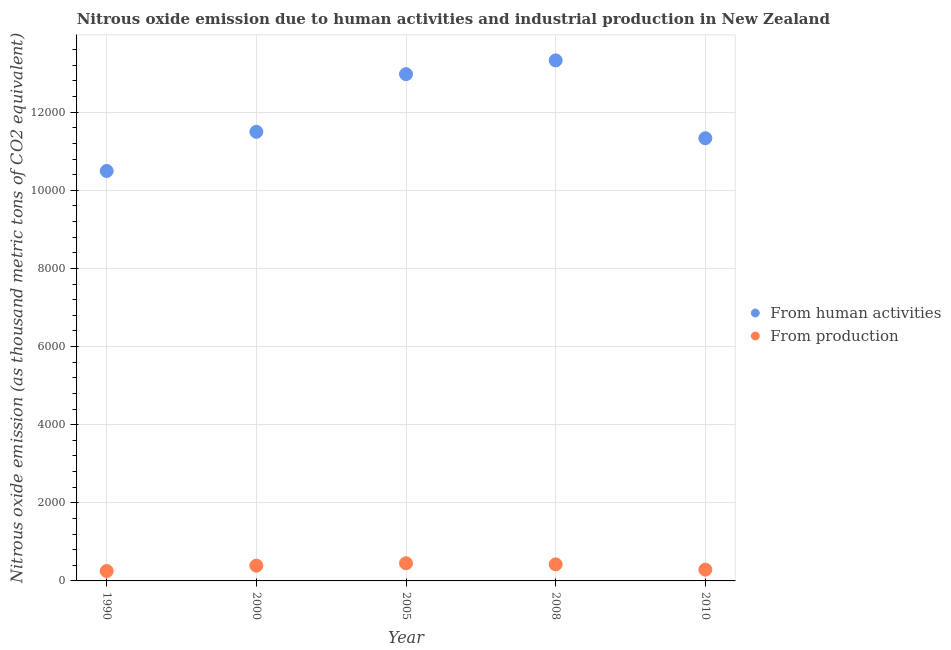What is the amount of emissions from human activities in 2005?
Make the answer very short. 1.30e+04. Across all years, what is the maximum amount of emissions generated from industries?
Your response must be concise. 452.7. Across all years, what is the minimum amount of emissions generated from industries?
Your answer should be compact. 253.4. In which year was the amount of emissions generated from industries minimum?
Offer a very short reply. 1990. What is the total amount of emissions from human activities in the graph?
Give a very brief answer. 5.96e+04. What is the difference between the amount of emissions generated from industries in 1990 and that in 2000?
Your answer should be very brief. -137.1. What is the difference between the amount of emissions from human activities in 1990 and the amount of emissions generated from industries in 2000?
Give a very brief answer. 1.01e+04. What is the average amount of emissions from human activities per year?
Provide a succinct answer. 1.19e+04. In the year 2005, what is the difference between the amount of emissions from human activities and amount of emissions generated from industries?
Provide a succinct answer. 1.25e+04. What is the ratio of the amount of emissions from human activities in 2000 to that in 2005?
Your answer should be compact. 0.89. What is the difference between the highest and the second highest amount of emissions generated from industries?
Your answer should be very brief. 28.7. What is the difference between the highest and the lowest amount of emissions generated from industries?
Offer a very short reply. 199.3. In how many years, is the amount of emissions generated from industries greater than the average amount of emissions generated from industries taken over all years?
Provide a short and direct response. 3. Is the sum of the amount of emissions generated from industries in 2008 and 2010 greater than the maximum amount of emissions from human activities across all years?
Offer a terse response. No. Does the amount of emissions generated from industries monotonically increase over the years?
Your answer should be very brief. No. How many dotlines are there?
Provide a succinct answer. 2. How many years are there in the graph?
Your response must be concise. 5. What is the difference between two consecutive major ticks on the Y-axis?
Keep it short and to the point. 2000. Where does the legend appear in the graph?
Your answer should be compact. Center right. How many legend labels are there?
Keep it short and to the point. 2. What is the title of the graph?
Ensure brevity in your answer.  Nitrous oxide emission due to human activities and industrial production in New Zealand. What is the label or title of the Y-axis?
Provide a succinct answer. Nitrous oxide emission (as thousand metric tons of CO2 equivalent). What is the Nitrous oxide emission (as thousand metric tons of CO2 equivalent) in From human activities in 1990?
Keep it short and to the point. 1.05e+04. What is the Nitrous oxide emission (as thousand metric tons of CO2 equivalent) of From production in 1990?
Your response must be concise. 253.4. What is the Nitrous oxide emission (as thousand metric tons of CO2 equivalent) of From human activities in 2000?
Offer a terse response. 1.15e+04. What is the Nitrous oxide emission (as thousand metric tons of CO2 equivalent) in From production in 2000?
Offer a very short reply. 390.5. What is the Nitrous oxide emission (as thousand metric tons of CO2 equivalent) in From human activities in 2005?
Give a very brief answer. 1.30e+04. What is the Nitrous oxide emission (as thousand metric tons of CO2 equivalent) in From production in 2005?
Make the answer very short. 452.7. What is the Nitrous oxide emission (as thousand metric tons of CO2 equivalent) in From human activities in 2008?
Offer a terse response. 1.33e+04. What is the Nitrous oxide emission (as thousand metric tons of CO2 equivalent) in From production in 2008?
Keep it short and to the point. 424. What is the Nitrous oxide emission (as thousand metric tons of CO2 equivalent) of From human activities in 2010?
Give a very brief answer. 1.13e+04. What is the Nitrous oxide emission (as thousand metric tons of CO2 equivalent) of From production in 2010?
Give a very brief answer. 288.3. Across all years, what is the maximum Nitrous oxide emission (as thousand metric tons of CO2 equivalent) in From human activities?
Your response must be concise. 1.33e+04. Across all years, what is the maximum Nitrous oxide emission (as thousand metric tons of CO2 equivalent) of From production?
Provide a succinct answer. 452.7. Across all years, what is the minimum Nitrous oxide emission (as thousand metric tons of CO2 equivalent) in From human activities?
Ensure brevity in your answer.  1.05e+04. Across all years, what is the minimum Nitrous oxide emission (as thousand metric tons of CO2 equivalent) of From production?
Ensure brevity in your answer.  253.4. What is the total Nitrous oxide emission (as thousand metric tons of CO2 equivalent) in From human activities in the graph?
Ensure brevity in your answer.  5.96e+04. What is the total Nitrous oxide emission (as thousand metric tons of CO2 equivalent) of From production in the graph?
Provide a succinct answer. 1808.9. What is the difference between the Nitrous oxide emission (as thousand metric tons of CO2 equivalent) in From human activities in 1990 and that in 2000?
Provide a short and direct response. -1002.9. What is the difference between the Nitrous oxide emission (as thousand metric tons of CO2 equivalent) in From production in 1990 and that in 2000?
Your response must be concise. -137.1. What is the difference between the Nitrous oxide emission (as thousand metric tons of CO2 equivalent) of From human activities in 1990 and that in 2005?
Make the answer very short. -2478.7. What is the difference between the Nitrous oxide emission (as thousand metric tons of CO2 equivalent) of From production in 1990 and that in 2005?
Your response must be concise. -199.3. What is the difference between the Nitrous oxide emission (as thousand metric tons of CO2 equivalent) in From human activities in 1990 and that in 2008?
Your response must be concise. -2830.6. What is the difference between the Nitrous oxide emission (as thousand metric tons of CO2 equivalent) in From production in 1990 and that in 2008?
Keep it short and to the point. -170.6. What is the difference between the Nitrous oxide emission (as thousand metric tons of CO2 equivalent) in From human activities in 1990 and that in 2010?
Provide a short and direct response. -838.1. What is the difference between the Nitrous oxide emission (as thousand metric tons of CO2 equivalent) of From production in 1990 and that in 2010?
Offer a terse response. -34.9. What is the difference between the Nitrous oxide emission (as thousand metric tons of CO2 equivalent) in From human activities in 2000 and that in 2005?
Give a very brief answer. -1475.8. What is the difference between the Nitrous oxide emission (as thousand metric tons of CO2 equivalent) of From production in 2000 and that in 2005?
Your response must be concise. -62.2. What is the difference between the Nitrous oxide emission (as thousand metric tons of CO2 equivalent) of From human activities in 2000 and that in 2008?
Your response must be concise. -1827.7. What is the difference between the Nitrous oxide emission (as thousand metric tons of CO2 equivalent) in From production in 2000 and that in 2008?
Ensure brevity in your answer.  -33.5. What is the difference between the Nitrous oxide emission (as thousand metric tons of CO2 equivalent) in From human activities in 2000 and that in 2010?
Provide a short and direct response. 164.8. What is the difference between the Nitrous oxide emission (as thousand metric tons of CO2 equivalent) of From production in 2000 and that in 2010?
Make the answer very short. 102.2. What is the difference between the Nitrous oxide emission (as thousand metric tons of CO2 equivalent) of From human activities in 2005 and that in 2008?
Offer a very short reply. -351.9. What is the difference between the Nitrous oxide emission (as thousand metric tons of CO2 equivalent) of From production in 2005 and that in 2008?
Ensure brevity in your answer.  28.7. What is the difference between the Nitrous oxide emission (as thousand metric tons of CO2 equivalent) of From human activities in 2005 and that in 2010?
Ensure brevity in your answer.  1640.6. What is the difference between the Nitrous oxide emission (as thousand metric tons of CO2 equivalent) in From production in 2005 and that in 2010?
Offer a terse response. 164.4. What is the difference between the Nitrous oxide emission (as thousand metric tons of CO2 equivalent) in From human activities in 2008 and that in 2010?
Provide a succinct answer. 1992.5. What is the difference between the Nitrous oxide emission (as thousand metric tons of CO2 equivalent) of From production in 2008 and that in 2010?
Offer a very short reply. 135.7. What is the difference between the Nitrous oxide emission (as thousand metric tons of CO2 equivalent) in From human activities in 1990 and the Nitrous oxide emission (as thousand metric tons of CO2 equivalent) in From production in 2000?
Give a very brief answer. 1.01e+04. What is the difference between the Nitrous oxide emission (as thousand metric tons of CO2 equivalent) in From human activities in 1990 and the Nitrous oxide emission (as thousand metric tons of CO2 equivalent) in From production in 2005?
Keep it short and to the point. 1.00e+04. What is the difference between the Nitrous oxide emission (as thousand metric tons of CO2 equivalent) in From human activities in 1990 and the Nitrous oxide emission (as thousand metric tons of CO2 equivalent) in From production in 2008?
Provide a succinct answer. 1.01e+04. What is the difference between the Nitrous oxide emission (as thousand metric tons of CO2 equivalent) of From human activities in 1990 and the Nitrous oxide emission (as thousand metric tons of CO2 equivalent) of From production in 2010?
Your answer should be compact. 1.02e+04. What is the difference between the Nitrous oxide emission (as thousand metric tons of CO2 equivalent) in From human activities in 2000 and the Nitrous oxide emission (as thousand metric tons of CO2 equivalent) in From production in 2005?
Offer a terse response. 1.10e+04. What is the difference between the Nitrous oxide emission (as thousand metric tons of CO2 equivalent) in From human activities in 2000 and the Nitrous oxide emission (as thousand metric tons of CO2 equivalent) in From production in 2008?
Keep it short and to the point. 1.11e+04. What is the difference between the Nitrous oxide emission (as thousand metric tons of CO2 equivalent) of From human activities in 2000 and the Nitrous oxide emission (as thousand metric tons of CO2 equivalent) of From production in 2010?
Make the answer very short. 1.12e+04. What is the difference between the Nitrous oxide emission (as thousand metric tons of CO2 equivalent) in From human activities in 2005 and the Nitrous oxide emission (as thousand metric tons of CO2 equivalent) in From production in 2008?
Offer a very short reply. 1.26e+04. What is the difference between the Nitrous oxide emission (as thousand metric tons of CO2 equivalent) of From human activities in 2005 and the Nitrous oxide emission (as thousand metric tons of CO2 equivalent) of From production in 2010?
Provide a succinct answer. 1.27e+04. What is the difference between the Nitrous oxide emission (as thousand metric tons of CO2 equivalent) of From human activities in 2008 and the Nitrous oxide emission (as thousand metric tons of CO2 equivalent) of From production in 2010?
Provide a short and direct response. 1.30e+04. What is the average Nitrous oxide emission (as thousand metric tons of CO2 equivalent) in From human activities per year?
Give a very brief answer. 1.19e+04. What is the average Nitrous oxide emission (as thousand metric tons of CO2 equivalent) of From production per year?
Offer a terse response. 361.78. In the year 1990, what is the difference between the Nitrous oxide emission (as thousand metric tons of CO2 equivalent) in From human activities and Nitrous oxide emission (as thousand metric tons of CO2 equivalent) in From production?
Offer a terse response. 1.02e+04. In the year 2000, what is the difference between the Nitrous oxide emission (as thousand metric tons of CO2 equivalent) in From human activities and Nitrous oxide emission (as thousand metric tons of CO2 equivalent) in From production?
Ensure brevity in your answer.  1.11e+04. In the year 2005, what is the difference between the Nitrous oxide emission (as thousand metric tons of CO2 equivalent) in From human activities and Nitrous oxide emission (as thousand metric tons of CO2 equivalent) in From production?
Your response must be concise. 1.25e+04. In the year 2008, what is the difference between the Nitrous oxide emission (as thousand metric tons of CO2 equivalent) of From human activities and Nitrous oxide emission (as thousand metric tons of CO2 equivalent) of From production?
Provide a short and direct response. 1.29e+04. In the year 2010, what is the difference between the Nitrous oxide emission (as thousand metric tons of CO2 equivalent) of From human activities and Nitrous oxide emission (as thousand metric tons of CO2 equivalent) of From production?
Offer a very short reply. 1.10e+04. What is the ratio of the Nitrous oxide emission (as thousand metric tons of CO2 equivalent) of From human activities in 1990 to that in 2000?
Your answer should be very brief. 0.91. What is the ratio of the Nitrous oxide emission (as thousand metric tons of CO2 equivalent) in From production in 1990 to that in 2000?
Your answer should be compact. 0.65. What is the ratio of the Nitrous oxide emission (as thousand metric tons of CO2 equivalent) of From human activities in 1990 to that in 2005?
Your response must be concise. 0.81. What is the ratio of the Nitrous oxide emission (as thousand metric tons of CO2 equivalent) in From production in 1990 to that in 2005?
Provide a short and direct response. 0.56. What is the ratio of the Nitrous oxide emission (as thousand metric tons of CO2 equivalent) in From human activities in 1990 to that in 2008?
Provide a succinct answer. 0.79. What is the ratio of the Nitrous oxide emission (as thousand metric tons of CO2 equivalent) in From production in 1990 to that in 2008?
Your response must be concise. 0.6. What is the ratio of the Nitrous oxide emission (as thousand metric tons of CO2 equivalent) in From human activities in 1990 to that in 2010?
Give a very brief answer. 0.93. What is the ratio of the Nitrous oxide emission (as thousand metric tons of CO2 equivalent) in From production in 1990 to that in 2010?
Offer a very short reply. 0.88. What is the ratio of the Nitrous oxide emission (as thousand metric tons of CO2 equivalent) of From human activities in 2000 to that in 2005?
Ensure brevity in your answer.  0.89. What is the ratio of the Nitrous oxide emission (as thousand metric tons of CO2 equivalent) of From production in 2000 to that in 2005?
Provide a succinct answer. 0.86. What is the ratio of the Nitrous oxide emission (as thousand metric tons of CO2 equivalent) in From human activities in 2000 to that in 2008?
Ensure brevity in your answer.  0.86. What is the ratio of the Nitrous oxide emission (as thousand metric tons of CO2 equivalent) of From production in 2000 to that in 2008?
Make the answer very short. 0.92. What is the ratio of the Nitrous oxide emission (as thousand metric tons of CO2 equivalent) in From human activities in 2000 to that in 2010?
Offer a very short reply. 1.01. What is the ratio of the Nitrous oxide emission (as thousand metric tons of CO2 equivalent) of From production in 2000 to that in 2010?
Offer a very short reply. 1.35. What is the ratio of the Nitrous oxide emission (as thousand metric tons of CO2 equivalent) of From human activities in 2005 to that in 2008?
Your answer should be compact. 0.97. What is the ratio of the Nitrous oxide emission (as thousand metric tons of CO2 equivalent) of From production in 2005 to that in 2008?
Make the answer very short. 1.07. What is the ratio of the Nitrous oxide emission (as thousand metric tons of CO2 equivalent) in From human activities in 2005 to that in 2010?
Provide a short and direct response. 1.14. What is the ratio of the Nitrous oxide emission (as thousand metric tons of CO2 equivalent) of From production in 2005 to that in 2010?
Make the answer very short. 1.57. What is the ratio of the Nitrous oxide emission (as thousand metric tons of CO2 equivalent) of From human activities in 2008 to that in 2010?
Your answer should be compact. 1.18. What is the ratio of the Nitrous oxide emission (as thousand metric tons of CO2 equivalent) in From production in 2008 to that in 2010?
Your answer should be compact. 1.47. What is the difference between the highest and the second highest Nitrous oxide emission (as thousand metric tons of CO2 equivalent) in From human activities?
Give a very brief answer. 351.9. What is the difference between the highest and the second highest Nitrous oxide emission (as thousand metric tons of CO2 equivalent) in From production?
Offer a terse response. 28.7. What is the difference between the highest and the lowest Nitrous oxide emission (as thousand metric tons of CO2 equivalent) of From human activities?
Give a very brief answer. 2830.6. What is the difference between the highest and the lowest Nitrous oxide emission (as thousand metric tons of CO2 equivalent) of From production?
Provide a succinct answer. 199.3. 